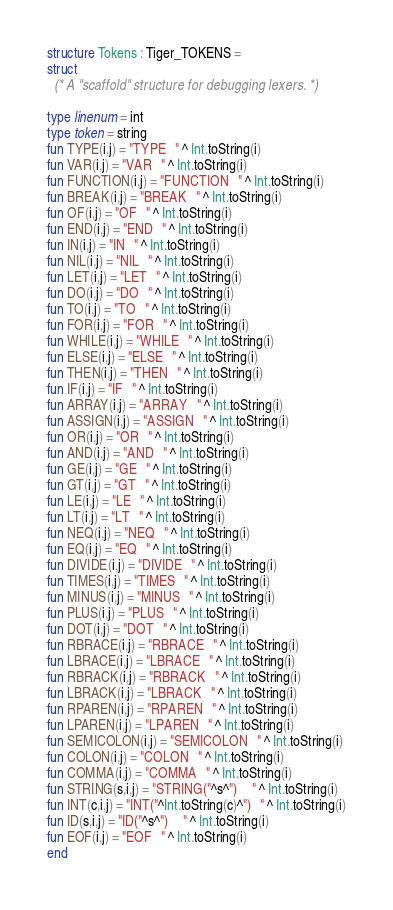Convert code to text. <code><loc_0><loc_0><loc_500><loc_500><_SML_>structure Tokens : Tiger_TOKENS =
struct
  (* A "scaffold" structure for debugging lexers. *)

type linenum = int
type token = string
fun TYPE(i,j) = "TYPE   " ^ Int.toString(i)
fun VAR(i,j) = "VAR   " ^ Int.toString(i)
fun FUNCTION(i,j) = "FUNCTION   " ^ Int.toString(i)
fun BREAK(i,j) = "BREAK   " ^ Int.toString(i)
fun OF(i,j) = "OF   " ^ Int.toString(i)
fun END(i,j) = "END   " ^ Int.toString(i)
fun IN(i,j) = "IN   " ^ Int.toString(i)
fun NIL(i,j) = "NIL   " ^ Int.toString(i)
fun LET(i,j) = "LET   " ^ Int.toString(i)
fun DO(i,j) = "DO   " ^ Int.toString(i)
fun TO(i,j) = "TO   " ^ Int.toString(i)
fun FOR(i,j) = "FOR   " ^ Int.toString(i)
fun WHILE(i,j) = "WHILE   " ^ Int.toString(i)
fun ELSE(i,j) = "ELSE   " ^ Int.toString(i)
fun THEN(i,j) = "THEN   " ^ Int.toString(i)
fun IF(i,j) = "IF   " ^ Int.toString(i)
fun ARRAY(i,j) = "ARRAY   " ^ Int.toString(i)
fun ASSIGN(i,j) = "ASSIGN   " ^ Int.toString(i)
fun OR(i,j) = "OR   " ^ Int.toString(i)
fun AND(i,j) = "AND   " ^ Int.toString(i)
fun GE(i,j) = "GE   " ^ Int.toString(i)
fun GT(i,j) = "GT   " ^ Int.toString(i)
fun LE(i,j) = "LE   " ^ Int.toString(i)
fun LT(i,j) = "LT   " ^ Int.toString(i)
fun NEQ(i,j) = "NEQ   " ^ Int.toString(i)
fun EQ(i,j) = "EQ   " ^ Int.toString(i)
fun DIVIDE(i,j) = "DIVIDE   " ^ Int.toString(i)
fun TIMES(i,j) = "TIMES   " ^ Int.toString(i)
fun MINUS(i,j) = "MINUS   " ^ Int.toString(i)
fun PLUS(i,j) = "PLUS   " ^ Int.toString(i)
fun DOT(i,j) = "DOT   " ^ Int.toString(i)
fun RBRACE(i,j) = "RBRACE   " ^ Int.toString(i)
fun LBRACE(i,j) = "LBRACE   " ^ Int.toString(i)
fun RBRACK(i,j) = "RBRACK   " ^ Int.toString(i)
fun LBRACK(i,j) = "LBRACK   " ^ Int.toString(i)
fun RPAREN(i,j) = "RPAREN   " ^ Int.toString(i)
fun LPAREN(i,j) = "LPAREN   " ^ Int.toString(i)
fun SEMICOLON(i,j) = "SEMICOLON   " ^ Int.toString(i)
fun COLON(i,j) = "COLON   " ^ Int.toString(i)
fun COMMA(i,j) = "COMMA   " ^ Int.toString(i)
fun STRING(s,i,j) = "STRING("^s^")     " ^ Int.toString(i)
fun INT(c,i,j) = "INT("^Int.toString(c)^")   " ^ Int.toString(i)
fun ID(s,i,j) = "ID("^s^")     " ^ Int.toString(i)
fun EOF(i,j) = "EOF   " ^ Int.toString(i)
end
</code> 